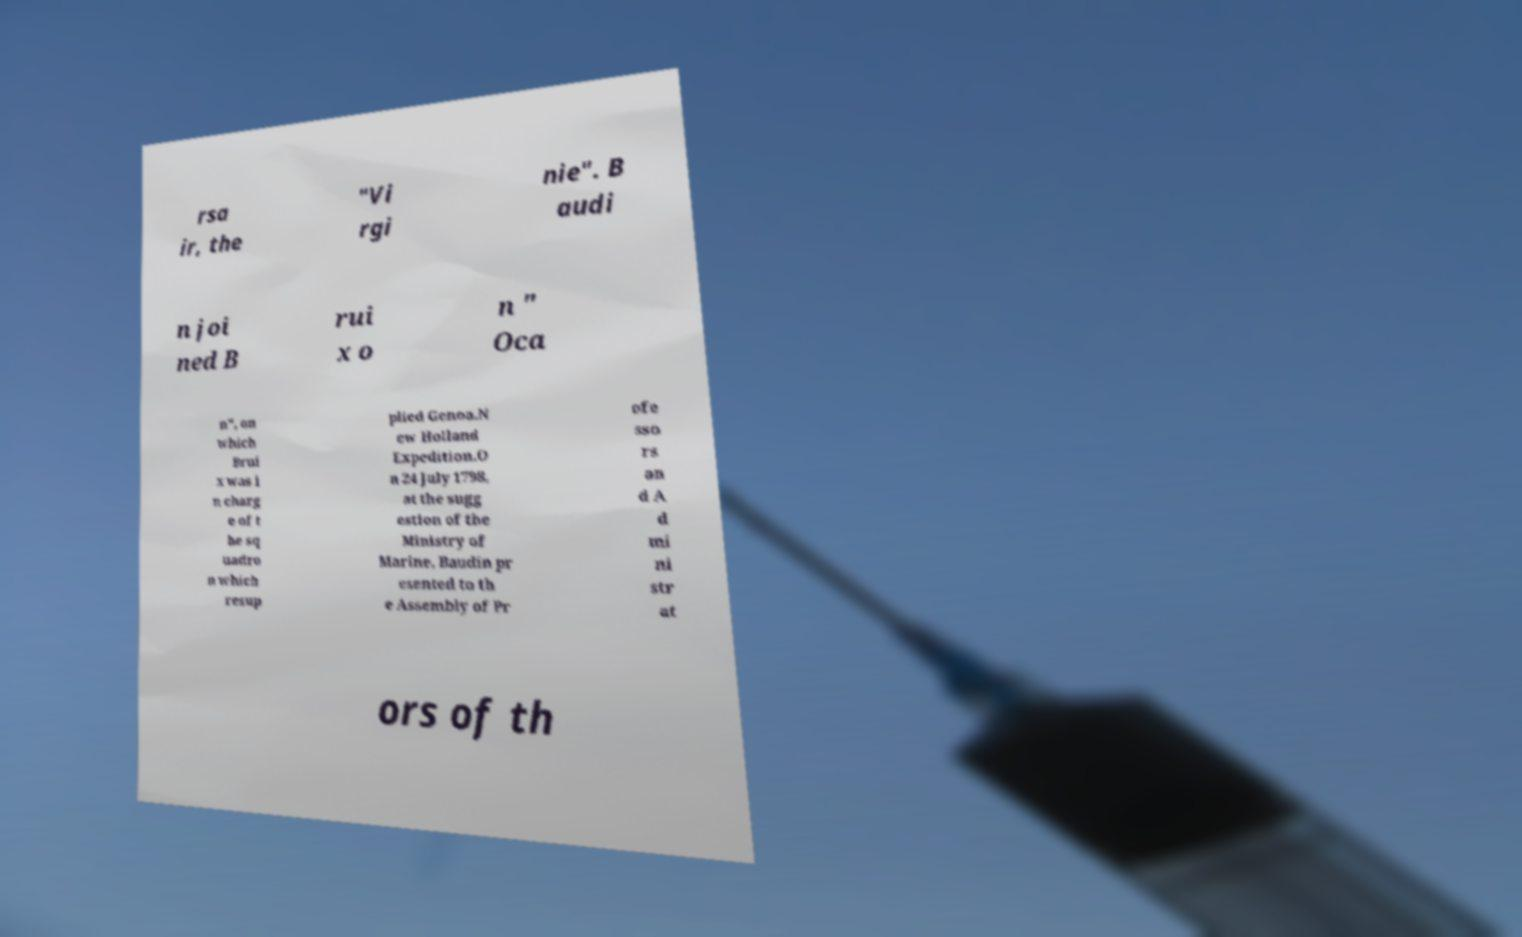Could you assist in decoding the text presented in this image and type it out clearly? rsa ir, the "Vi rgi nie". B audi n joi ned B rui x o n " Oca n", on which Brui x was i n charg e of t he sq uadro n which resup plied Genoa.N ew Holland Expedition.O n 24 July 1798, at the sugg estion of the Ministry of Marine, Baudin pr esented to th e Assembly of Pr ofe sso rs an d A d mi ni str at ors of th 